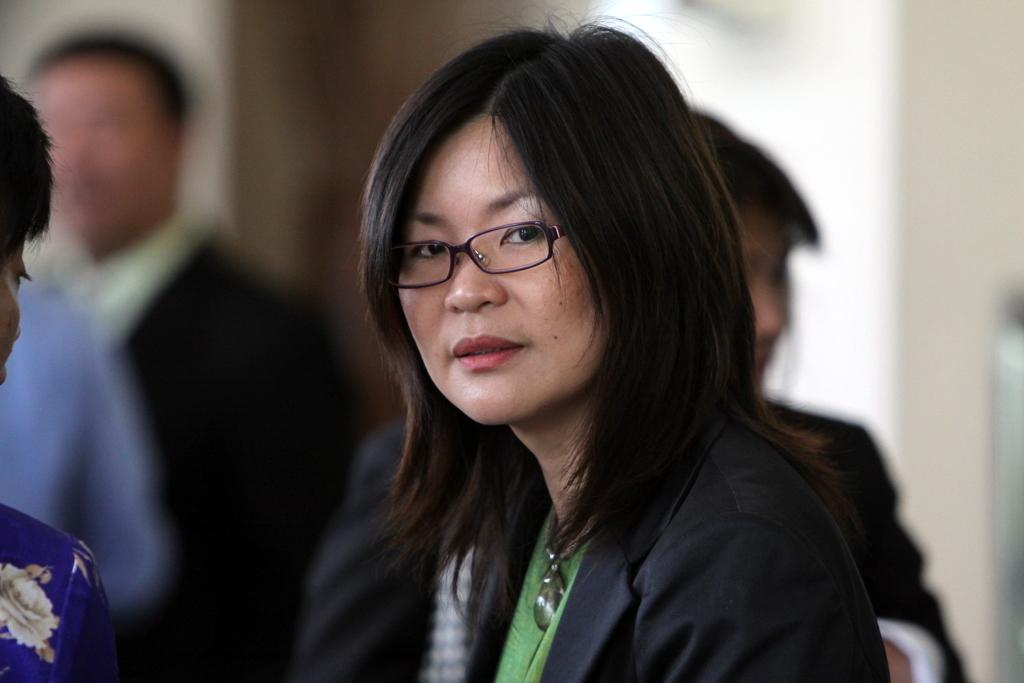What is the main subject of the image? The main subject of the image is a group of people. Can you describe any specific details about the people in the image? One woman in the group is wearing spectacles. What type of linen is being used to cover the wealth of the brothers in the image? There is no mention of linen, wealth, or brothers in the image, so this question cannot be answered. 